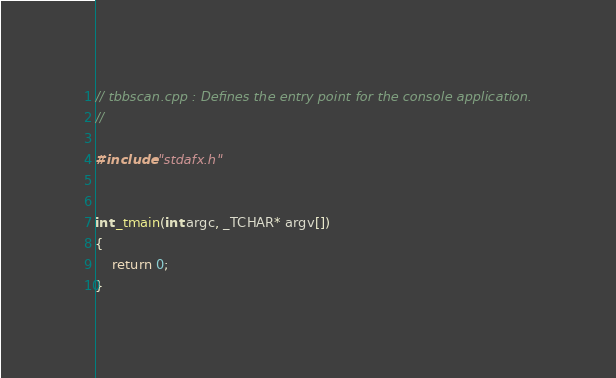Convert code to text. <code><loc_0><loc_0><loc_500><loc_500><_C++_>// tbbscan.cpp : Defines the entry point for the console application.
//

#include "stdafx.h"


int _tmain(int argc, _TCHAR* argv[])
{
	return 0;
}

</code> 